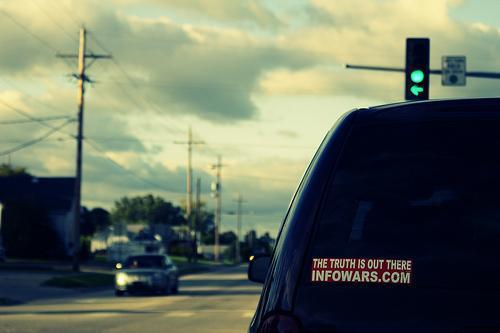How many cars are there?
Give a very brief answer. 2. 